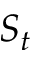<formula> <loc_0><loc_0><loc_500><loc_500>S _ { t }</formula> 